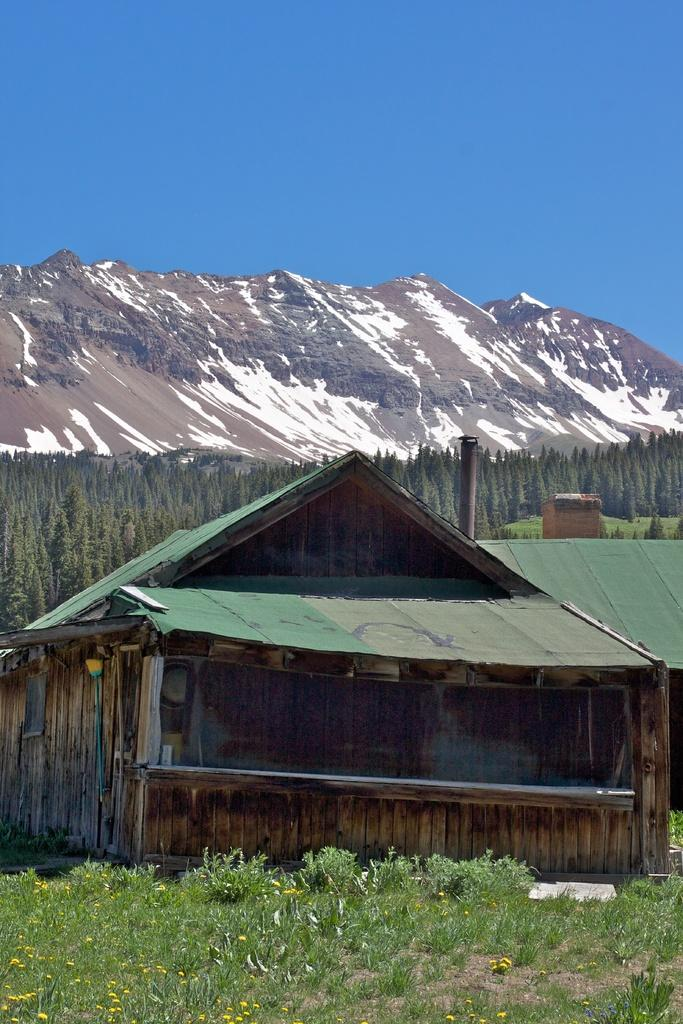What type of structures can be seen in the image? There are houses in the image. What type of vegetation is present in the image? There are trees, plants, and grass in the image. What is the terrain feature in the image? There is a hill in the image. What is visible in the background of the image? The sky is visible in the background of the image. How many cars are parked on the hill in the image? There are no cars present in the image. What color is the shirt worn by the tree in the image? There is no shirt present in the image, as trees do not wear clothing. 